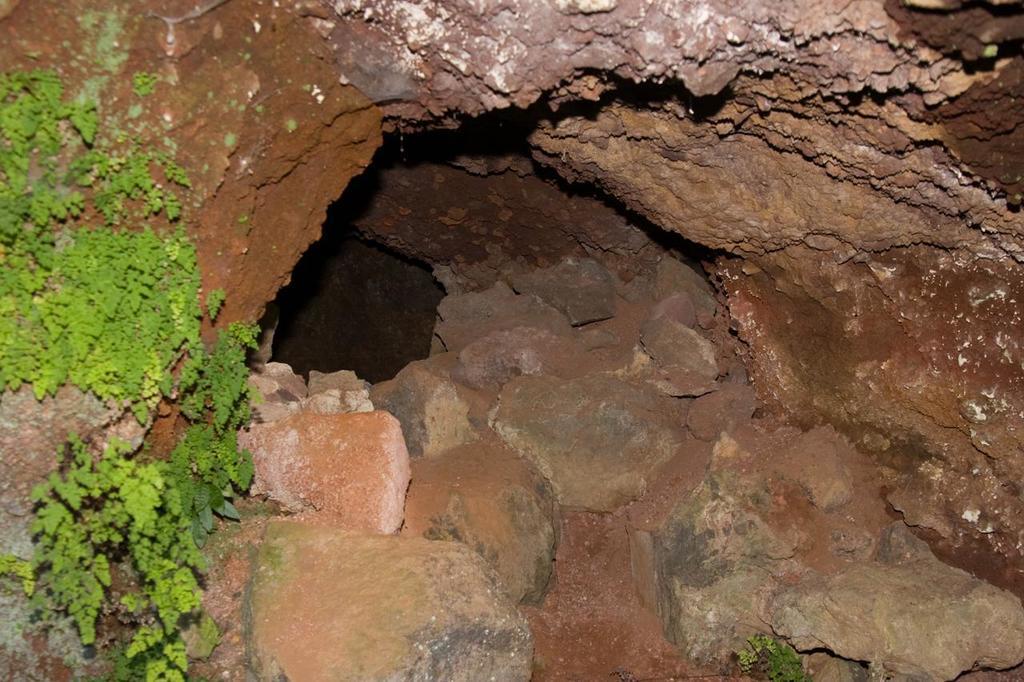Can you describe this image briefly? In this picture I can see rocks and leaves. 